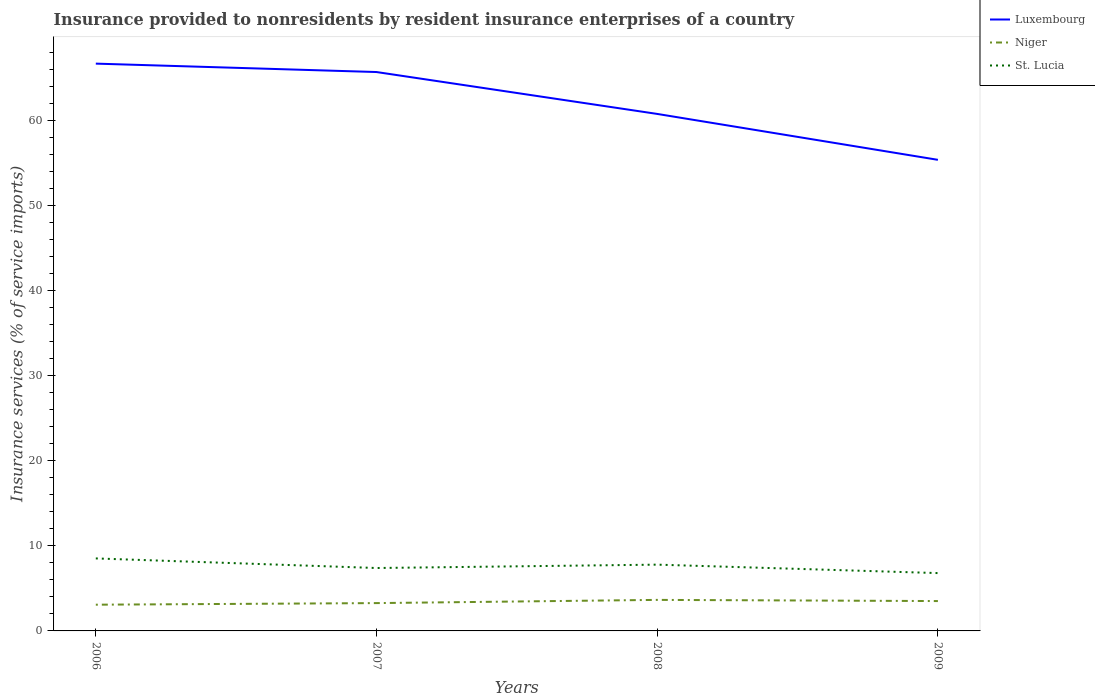Does the line corresponding to St. Lucia intersect with the line corresponding to Niger?
Your response must be concise. No. Is the number of lines equal to the number of legend labels?
Your answer should be very brief. Yes. Across all years, what is the maximum insurance provided to nonresidents in Luxembourg?
Your answer should be compact. 55.41. In which year was the insurance provided to nonresidents in Niger maximum?
Your response must be concise. 2006. What is the total insurance provided to nonresidents in Niger in the graph?
Give a very brief answer. 0.14. What is the difference between the highest and the second highest insurance provided to nonresidents in St. Lucia?
Ensure brevity in your answer.  1.72. Is the insurance provided to nonresidents in St. Lucia strictly greater than the insurance provided to nonresidents in Niger over the years?
Your answer should be compact. No. How many lines are there?
Provide a succinct answer. 3. What is the difference between two consecutive major ticks on the Y-axis?
Keep it short and to the point. 10. Are the values on the major ticks of Y-axis written in scientific E-notation?
Ensure brevity in your answer.  No. Where does the legend appear in the graph?
Provide a succinct answer. Top right. How many legend labels are there?
Your answer should be very brief. 3. How are the legend labels stacked?
Your answer should be very brief. Vertical. What is the title of the graph?
Your response must be concise. Insurance provided to nonresidents by resident insurance enterprises of a country. What is the label or title of the X-axis?
Your response must be concise. Years. What is the label or title of the Y-axis?
Your answer should be very brief. Insurance services (% of service imports). What is the Insurance services (% of service imports) of Luxembourg in 2006?
Your response must be concise. 66.73. What is the Insurance services (% of service imports) of Niger in 2006?
Offer a very short reply. 3.09. What is the Insurance services (% of service imports) of St. Lucia in 2006?
Give a very brief answer. 8.53. What is the Insurance services (% of service imports) in Luxembourg in 2007?
Ensure brevity in your answer.  65.74. What is the Insurance services (% of service imports) in Niger in 2007?
Keep it short and to the point. 3.27. What is the Insurance services (% of service imports) in St. Lucia in 2007?
Your answer should be compact. 7.4. What is the Insurance services (% of service imports) in Luxembourg in 2008?
Give a very brief answer. 60.81. What is the Insurance services (% of service imports) in Niger in 2008?
Offer a very short reply. 3.65. What is the Insurance services (% of service imports) of St. Lucia in 2008?
Make the answer very short. 7.8. What is the Insurance services (% of service imports) of Luxembourg in 2009?
Offer a very short reply. 55.41. What is the Insurance services (% of service imports) of Niger in 2009?
Your answer should be very brief. 3.51. What is the Insurance services (% of service imports) in St. Lucia in 2009?
Give a very brief answer. 6.8. Across all years, what is the maximum Insurance services (% of service imports) of Luxembourg?
Provide a short and direct response. 66.73. Across all years, what is the maximum Insurance services (% of service imports) of Niger?
Your answer should be compact. 3.65. Across all years, what is the maximum Insurance services (% of service imports) of St. Lucia?
Give a very brief answer. 8.53. Across all years, what is the minimum Insurance services (% of service imports) of Luxembourg?
Provide a succinct answer. 55.41. Across all years, what is the minimum Insurance services (% of service imports) of Niger?
Offer a terse response. 3.09. Across all years, what is the minimum Insurance services (% of service imports) in St. Lucia?
Your response must be concise. 6.8. What is the total Insurance services (% of service imports) in Luxembourg in the graph?
Your response must be concise. 248.7. What is the total Insurance services (% of service imports) in Niger in the graph?
Your answer should be very brief. 13.52. What is the total Insurance services (% of service imports) of St. Lucia in the graph?
Ensure brevity in your answer.  30.53. What is the difference between the Insurance services (% of service imports) in Niger in 2006 and that in 2007?
Ensure brevity in your answer.  -0.19. What is the difference between the Insurance services (% of service imports) in St. Lucia in 2006 and that in 2007?
Your response must be concise. 1.13. What is the difference between the Insurance services (% of service imports) of Luxembourg in 2006 and that in 2008?
Your response must be concise. 5.92. What is the difference between the Insurance services (% of service imports) of Niger in 2006 and that in 2008?
Provide a short and direct response. -0.57. What is the difference between the Insurance services (% of service imports) of St. Lucia in 2006 and that in 2008?
Give a very brief answer. 0.73. What is the difference between the Insurance services (% of service imports) in Luxembourg in 2006 and that in 2009?
Offer a terse response. 11.32. What is the difference between the Insurance services (% of service imports) of Niger in 2006 and that in 2009?
Make the answer very short. -0.43. What is the difference between the Insurance services (% of service imports) of St. Lucia in 2006 and that in 2009?
Give a very brief answer. 1.72. What is the difference between the Insurance services (% of service imports) in Luxembourg in 2007 and that in 2008?
Your response must be concise. 4.93. What is the difference between the Insurance services (% of service imports) in Niger in 2007 and that in 2008?
Your answer should be very brief. -0.38. What is the difference between the Insurance services (% of service imports) in St. Lucia in 2007 and that in 2008?
Make the answer very short. -0.4. What is the difference between the Insurance services (% of service imports) in Luxembourg in 2007 and that in 2009?
Ensure brevity in your answer.  10.33. What is the difference between the Insurance services (% of service imports) of Niger in 2007 and that in 2009?
Your answer should be very brief. -0.24. What is the difference between the Insurance services (% of service imports) in St. Lucia in 2007 and that in 2009?
Offer a terse response. 0.6. What is the difference between the Insurance services (% of service imports) of Luxembourg in 2008 and that in 2009?
Provide a short and direct response. 5.4. What is the difference between the Insurance services (% of service imports) of Niger in 2008 and that in 2009?
Offer a terse response. 0.14. What is the difference between the Insurance services (% of service imports) in Luxembourg in 2006 and the Insurance services (% of service imports) in Niger in 2007?
Ensure brevity in your answer.  63.46. What is the difference between the Insurance services (% of service imports) of Luxembourg in 2006 and the Insurance services (% of service imports) of St. Lucia in 2007?
Offer a terse response. 59.33. What is the difference between the Insurance services (% of service imports) in Niger in 2006 and the Insurance services (% of service imports) in St. Lucia in 2007?
Give a very brief answer. -4.31. What is the difference between the Insurance services (% of service imports) of Luxembourg in 2006 and the Insurance services (% of service imports) of Niger in 2008?
Ensure brevity in your answer.  63.08. What is the difference between the Insurance services (% of service imports) of Luxembourg in 2006 and the Insurance services (% of service imports) of St. Lucia in 2008?
Give a very brief answer. 58.93. What is the difference between the Insurance services (% of service imports) in Niger in 2006 and the Insurance services (% of service imports) in St. Lucia in 2008?
Your answer should be compact. -4.71. What is the difference between the Insurance services (% of service imports) of Luxembourg in 2006 and the Insurance services (% of service imports) of Niger in 2009?
Keep it short and to the point. 63.22. What is the difference between the Insurance services (% of service imports) in Luxembourg in 2006 and the Insurance services (% of service imports) in St. Lucia in 2009?
Give a very brief answer. 59.93. What is the difference between the Insurance services (% of service imports) in Niger in 2006 and the Insurance services (% of service imports) in St. Lucia in 2009?
Your answer should be very brief. -3.72. What is the difference between the Insurance services (% of service imports) of Luxembourg in 2007 and the Insurance services (% of service imports) of Niger in 2008?
Offer a very short reply. 62.09. What is the difference between the Insurance services (% of service imports) of Luxembourg in 2007 and the Insurance services (% of service imports) of St. Lucia in 2008?
Your answer should be very brief. 57.94. What is the difference between the Insurance services (% of service imports) in Niger in 2007 and the Insurance services (% of service imports) in St. Lucia in 2008?
Keep it short and to the point. -4.52. What is the difference between the Insurance services (% of service imports) of Luxembourg in 2007 and the Insurance services (% of service imports) of Niger in 2009?
Your answer should be very brief. 62.23. What is the difference between the Insurance services (% of service imports) in Luxembourg in 2007 and the Insurance services (% of service imports) in St. Lucia in 2009?
Offer a terse response. 58.94. What is the difference between the Insurance services (% of service imports) in Niger in 2007 and the Insurance services (% of service imports) in St. Lucia in 2009?
Offer a very short reply. -3.53. What is the difference between the Insurance services (% of service imports) of Luxembourg in 2008 and the Insurance services (% of service imports) of Niger in 2009?
Offer a terse response. 57.3. What is the difference between the Insurance services (% of service imports) of Luxembourg in 2008 and the Insurance services (% of service imports) of St. Lucia in 2009?
Ensure brevity in your answer.  54.01. What is the difference between the Insurance services (% of service imports) of Niger in 2008 and the Insurance services (% of service imports) of St. Lucia in 2009?
Your response must be concise. -3.15. What is the average Insurance services (% of service imports) in Luxembourg per year?
Keep it short and to the point. 62.17. What is the average Insurance services (% of service imports) of Niger per year?
Keep it short and to the point. 3.38. What is the average Insurance services (% of service imports) of St. Lucia per year?
Provide a short and direct response. 7.63. In the year 2006, what is the difference between the Insurance services (% of service imports) of Luxembourg and Insurance services (% of service imports) of Niger?
Offer a very short reply. 63.65. In the year 2006, what is the difference between the Insurance services (% of service imports) in Luxembourg and Insurance services (% of service imports) in St. Lucia?
Your response must be concise. 58.2. In the year 2006, what is the difference between the Insurance services (% of service imports) of Niger and Insurance services (% of service imports) of St. Lucia?
Your answer should be very brief. -5.44. In the year 2007, what is the difference between the Insurance services (% of service imports) in Luxembourg and Insurance services (% of service imports) in Niger?
Offer a very short reply. 62.47. In the year 2007, what is the difference between the Insurance services (% of service imports) of Luxembourg and Insurance services (% of service imports) of St. Lucia?
Offer a terse response. 58.34. In the year 2007, what is the difference between the Insurance services (% of service imports) of Niger and Insurance services (% of service imports) of St. Lucia?
Provide a succinct answer. -4.13. In the year 2008, what is the difference between the Insurance services (% of service imports) of Luxembourg and Insurance services (% of service imports) of Niger?
Offer a terse response. 57.16. In the year 2008, what is the difference between the Insurance services (% of service imports) in Luxembourg and Insurance services (% of service imports) in St. Lucia?
Your answer should be compact. 53.02. In the year 2008, what is the difference between the Insurance services (% of service imports) of Niger and Insurance services (% of service imports) of St. Lucia?
Keep it short and to the point. -4.15. In the year 2009, what is the difference between the Insurance services (% of service imports) in Luxembourg and Insurance services (% of service imports) in Niger?
Your response must be concise. 51.9. In the year 2009, what is the difference between the Insurance services (% of service imports) in Luxembourg and Insurance services (% of service imports) in St. Lucia?
Make the answer very short. 48.61. In the year 2009, what is the difference between the Insurance services (% of service imports) of Niger and Insurance services (% of service imports) of St. Lucia?
Provide a succinct answer. -3.29. What is the ratio of the Insurance services (% of service imports) of Niger in 2006 to that in 2007?
Keep it short and to the point. 0.94. What is the ratio of the Insurance services (% of service imports) in St. Lucia in 2006 to that in 2007?
Your response must be concise. 1.15. What is the ratio of the Insurance services (% of service imports) in Luxembourg in 2006 to that in 2008?
Offer a terse response. 1.1. What is the ratio of the Insurance services (% of service imports) of Niger in 2006 to that in 2008?
Provide a succinct answer. 0.85. What is the ratio of the Insurance services (% of service imports) in St. Lucia in 2006 to that in 2008?
Keep it short and to the point. 1.09. What is the ratio of the Insurance services (% of service imports) of Luxembourg in 2006 to that in 2009?
Keep it short and to the point. 1.2. What is the ratio of the Insurance services (% of service imports) in Niger in 2006 to that in 2009?
Your answer should be very brief. 0.88. What is the ratio of the Insurance services (% of service imports) in St. Lucia in 2006 to that in 2009?
Ensure brevity in your answer.  1.25. What is the ratio of the Insurance services (% of service imports) in Luxembourg in 2007 to that in 2008?
Provide a succinct answer. 1.08. What is the ratio of the Insurance services (% of service imports) in Niger in 2007 to that in 2008?
Offer a terse response. 0.9. What is the ratio of the Insurance services (% of service imports) in St. Lucia in 2007 to that in 2008?
Offer a terse response. 0.95. What is the ratio of the Insurance services (% of service imports) in Luxembourg in 2007 to that in 2009?
Provide a short and direct response. 1.19. What is the ratio of the Insurance services (% of service imports) of Niger in 2007 to that in 2009?
Your answer should be compact. 0.93. What is the ratio of the Insurance services (% of service imports) in St. Lucia in 2007 to that in 2009?
Ensure brevity in your answer.  1.09. What is the ratio of the Insurance services (% of service imports) of Luxembourg in 2008 to that in 2009?
Provide a short and direct response. 1.1. What is the ratio of the Insurance services (% of service imports) of Niger in 2008 to that in 2009?
Your response must be concise. 1.04. What is the ratio of the Insurance services (% of service imports) of St. Lucia in 2008 to that in 2009?
Your answer should be very brief. 1.15. What is the difference between the highest and the second highest Insurance services (% of service imports) in Niger?
Your response must be concise. 0.14. What is the difference between the highest and the second highest Insurance services (% of service imports) in St. Lucia?
Your answer should be compact. 0.73. What is the difference between the highest and the lowest Insurance services (% of service imports) in Luxembourg?
Ensure brevity in your answer.  11.32. What is the difference between the highest and the lowest Insurance services (% of service imports) of Niger?
Keep it short and to the point. 0.57. What is the difference between the highest and the lowest Insurance services (% of service imports) in St. Lucia?
Your answer should be very brief. 1.72. 